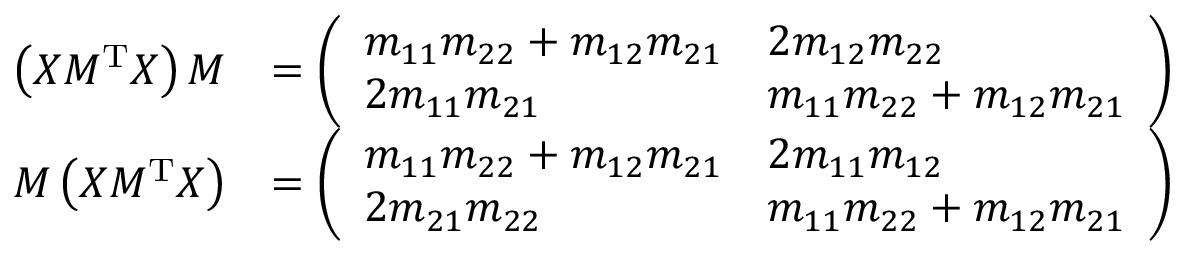Convert formula to latex. <formula><loc_0><loc_0><loc_500><loc_500>\begin{array} { r l } { \left ( X M ^ { T } X \right ) M } & { = \left ( \begin{array} { l l } { m _ { 1 1 } m _ { 2 2 } + m _ { 1 2 } m _ { 2 1 } } & { 2 m _ { 1 2 } m _ { 2 2 } } \\ { 2 m _ { 1 1 } m _ { 2 1 } } & { m _ { 1 1 } m _ { 2 2 } + m _ { 1 2 } m _ { 2 1 } } \end{array} \right ) } \\ { M \left ( X M ^ { T } X \right ) } & { = \left ( \begin{array} { l l } { m _ { 1 1 } m _ { 2 2 } + m _ { 1 2 } m _ { 2 1 } } & { 2 m _ { 1 1 } m _ { 1 2 } } \\ { 2 m _ { 2 1 } m _ { 2 2 } } & { m _ { 1 1 } m _ { 2 2 } + m _ { 1 2 } m _ { 2 1 } } \end{array} \right ) } \end{array}</formula> 